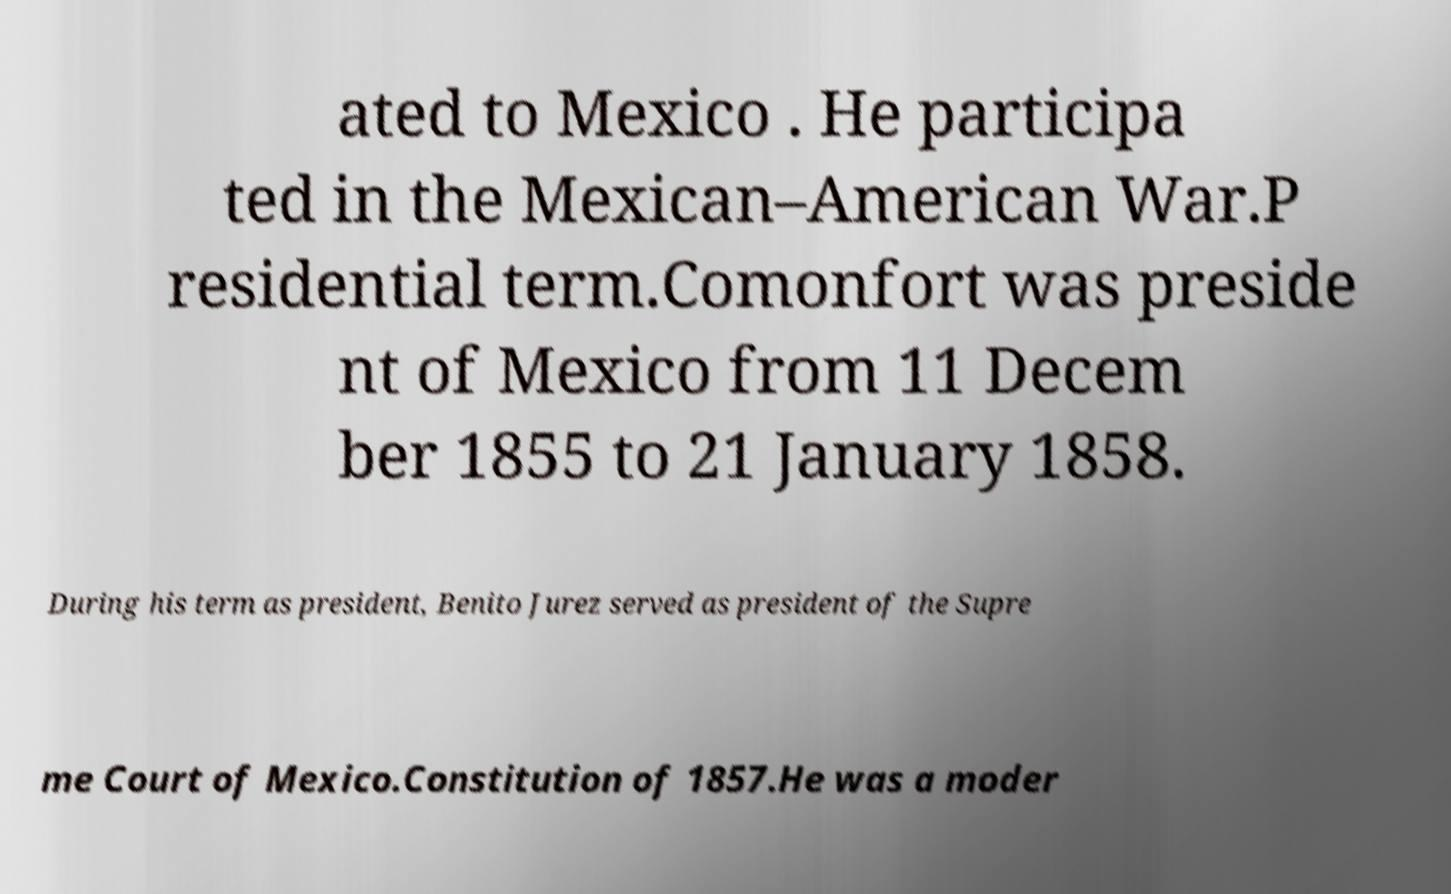There's text embedded in this image that I need extracted. Can you transcribe it verbatim? ated to Mexico . He participa ted in the Mexican–American War.P residential term.Comonfort was preside nt of Mexico from 11 Decem ber 1855 to 21 January 1858. During his term as president, Benito Jurez served as president of the Supre me Court of Mexico.Constitution of 1857.He was a moder 